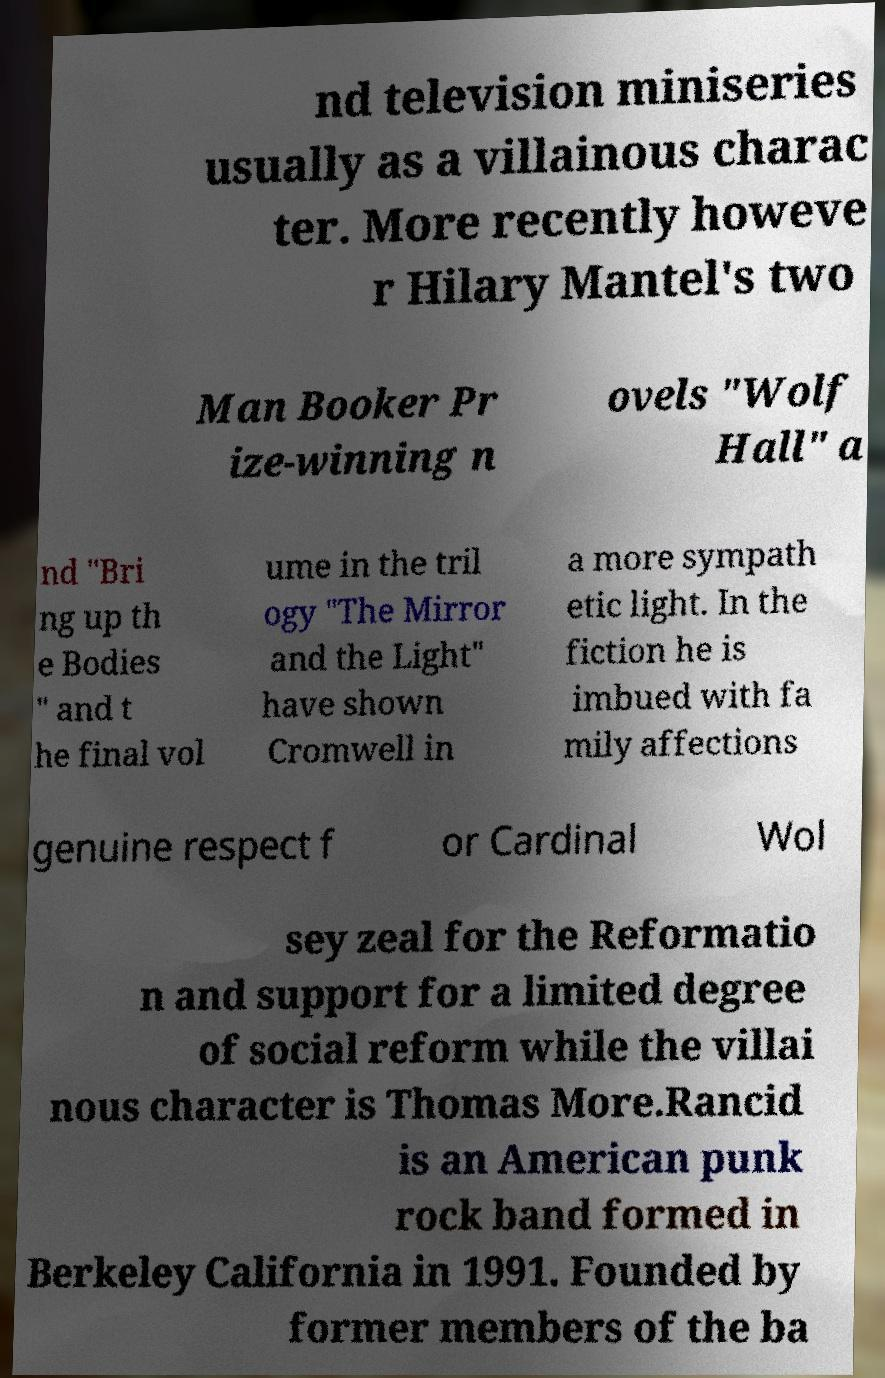Please identify and transcribe the text found in this image. nd television miniseries usually as a villainous charac ter. More recently howeve r Hilary Mantel's two Man Booker Pr ize-winning n ovels "Wolf Hall" a nd "Bri ng up th e Bodies " and t he final vol ume in the tril ogy "The Mirror and the Light" have shown Cromwell in a more sympath etic light. In the fiction he is imbued with fa mily affections genuine respect f or Cardinal Wol sey zeal for the Reformatio n and support for a limited degree of social reform while the villai nous character is Thomas More.Rancid is an American punk rock band formed in Berkeley California in 1991. Founded by former members of the ba 